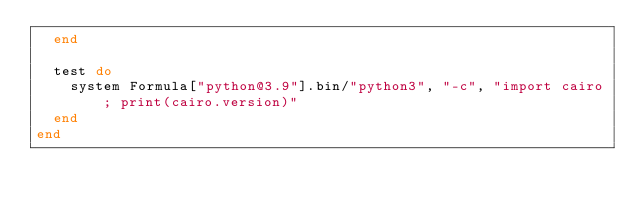<code> <loc_0><loc_0><loc_500><loc_500><_Ruby_>  end

  test do
    system Formula["python@3.9"].bin/"python3", "-c", "import cairo; print(cairo.version)"
  end
end
</code> 